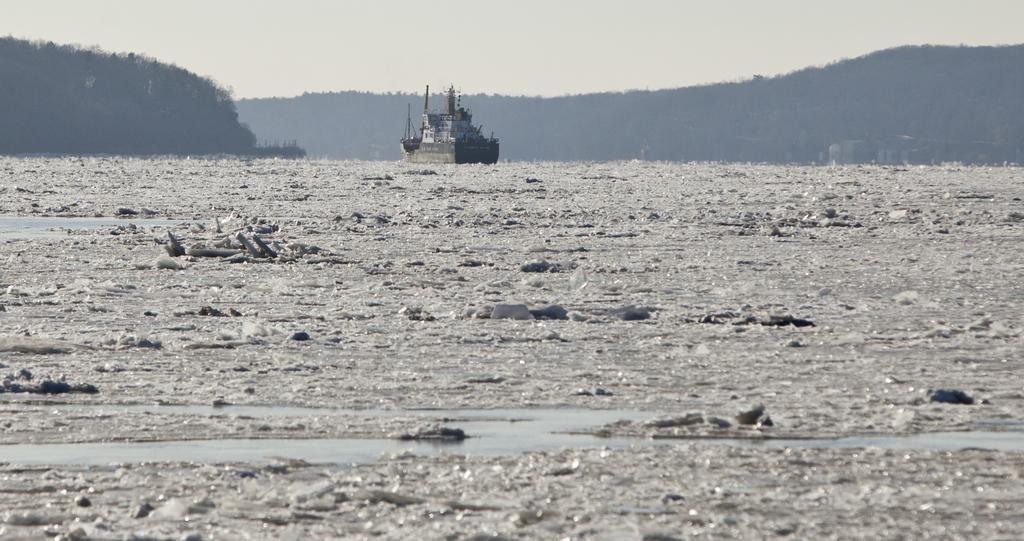In one or two sentences, can you explain what this image depicts? In the picture we can see a water with ice glaciers and far away from it, we can see a ship with some poles on it and behind it, we can see hills with trees on it and behind it we can see a sky. 